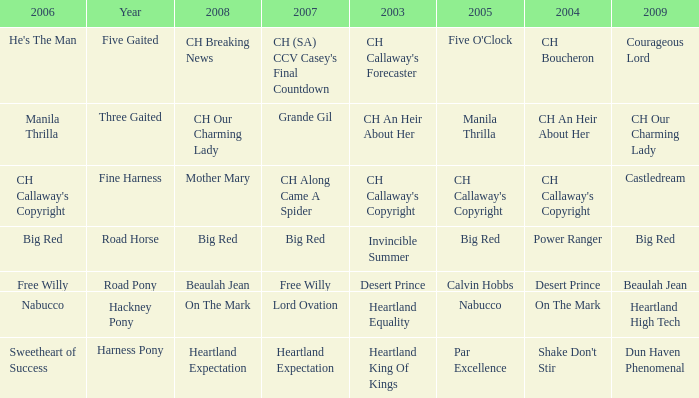What year is the 2007 big red? Road Horse. 